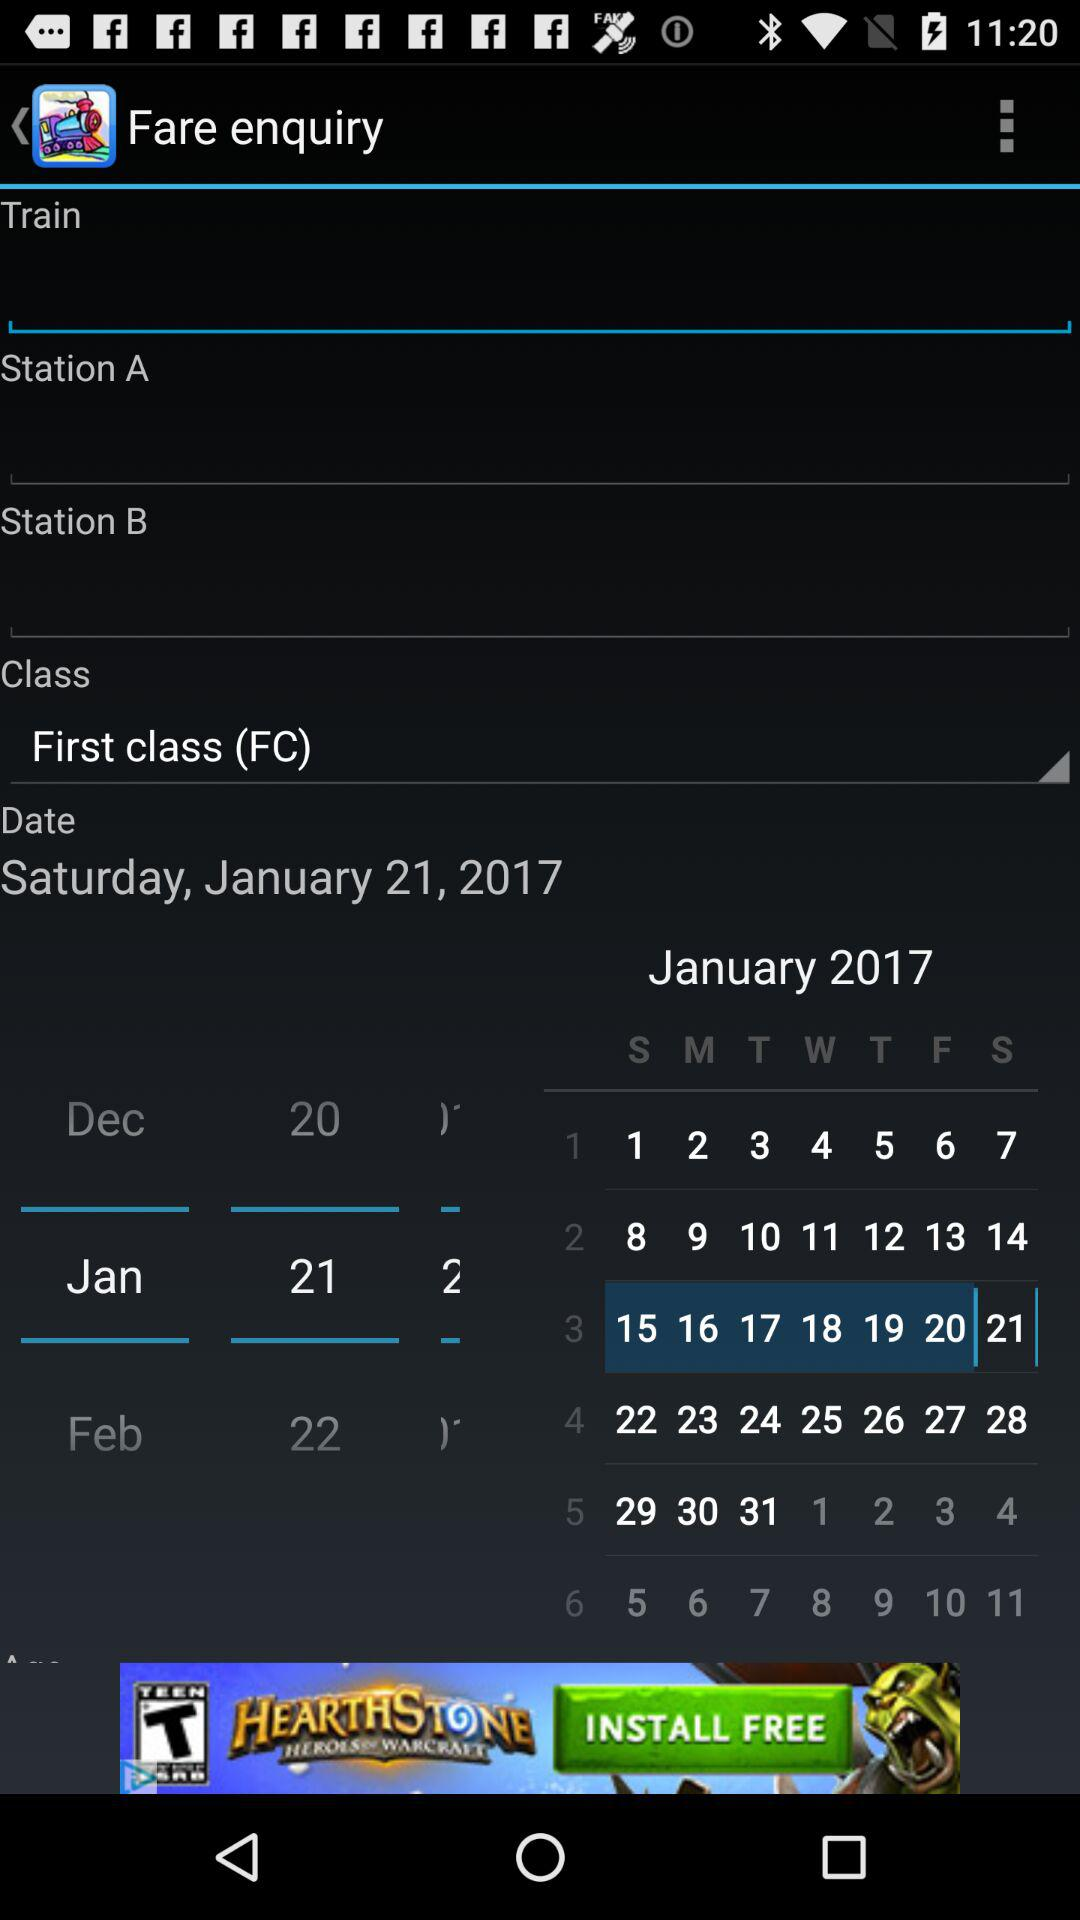What is the weekday of January, 21st? The day is Saturday. 